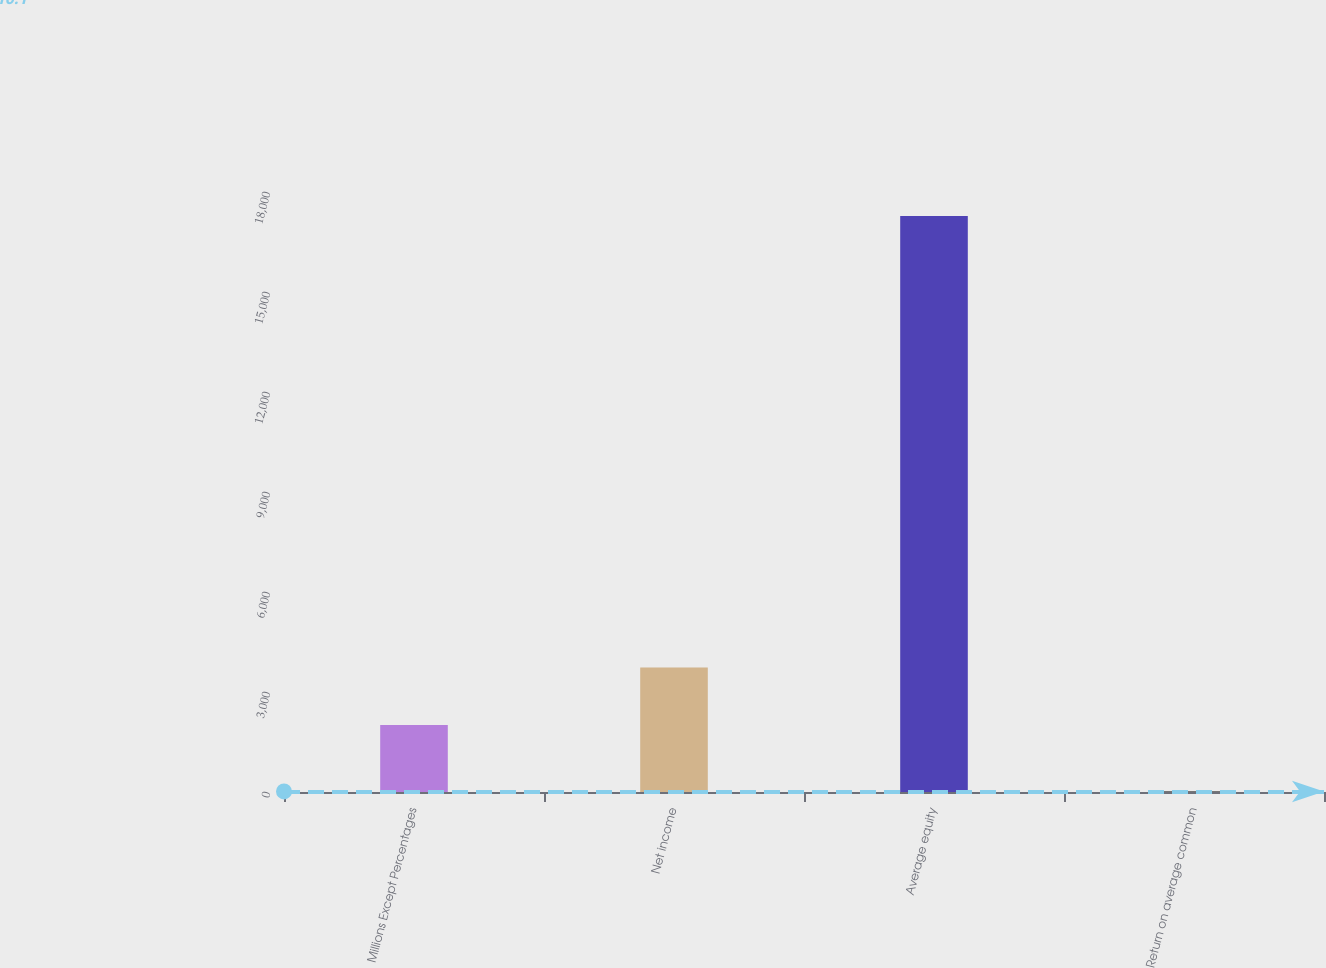<chart> <loc_0><loc_0><loc_500><loc_500><bar_chart><fcel>Millions Except Percentages<fcel>Net income<fcel>Average equity<fcel>Return on average common<nl><fcel>2010<fcel>3736.59<fcel>17282<fcel>16.1<nl></chart> 